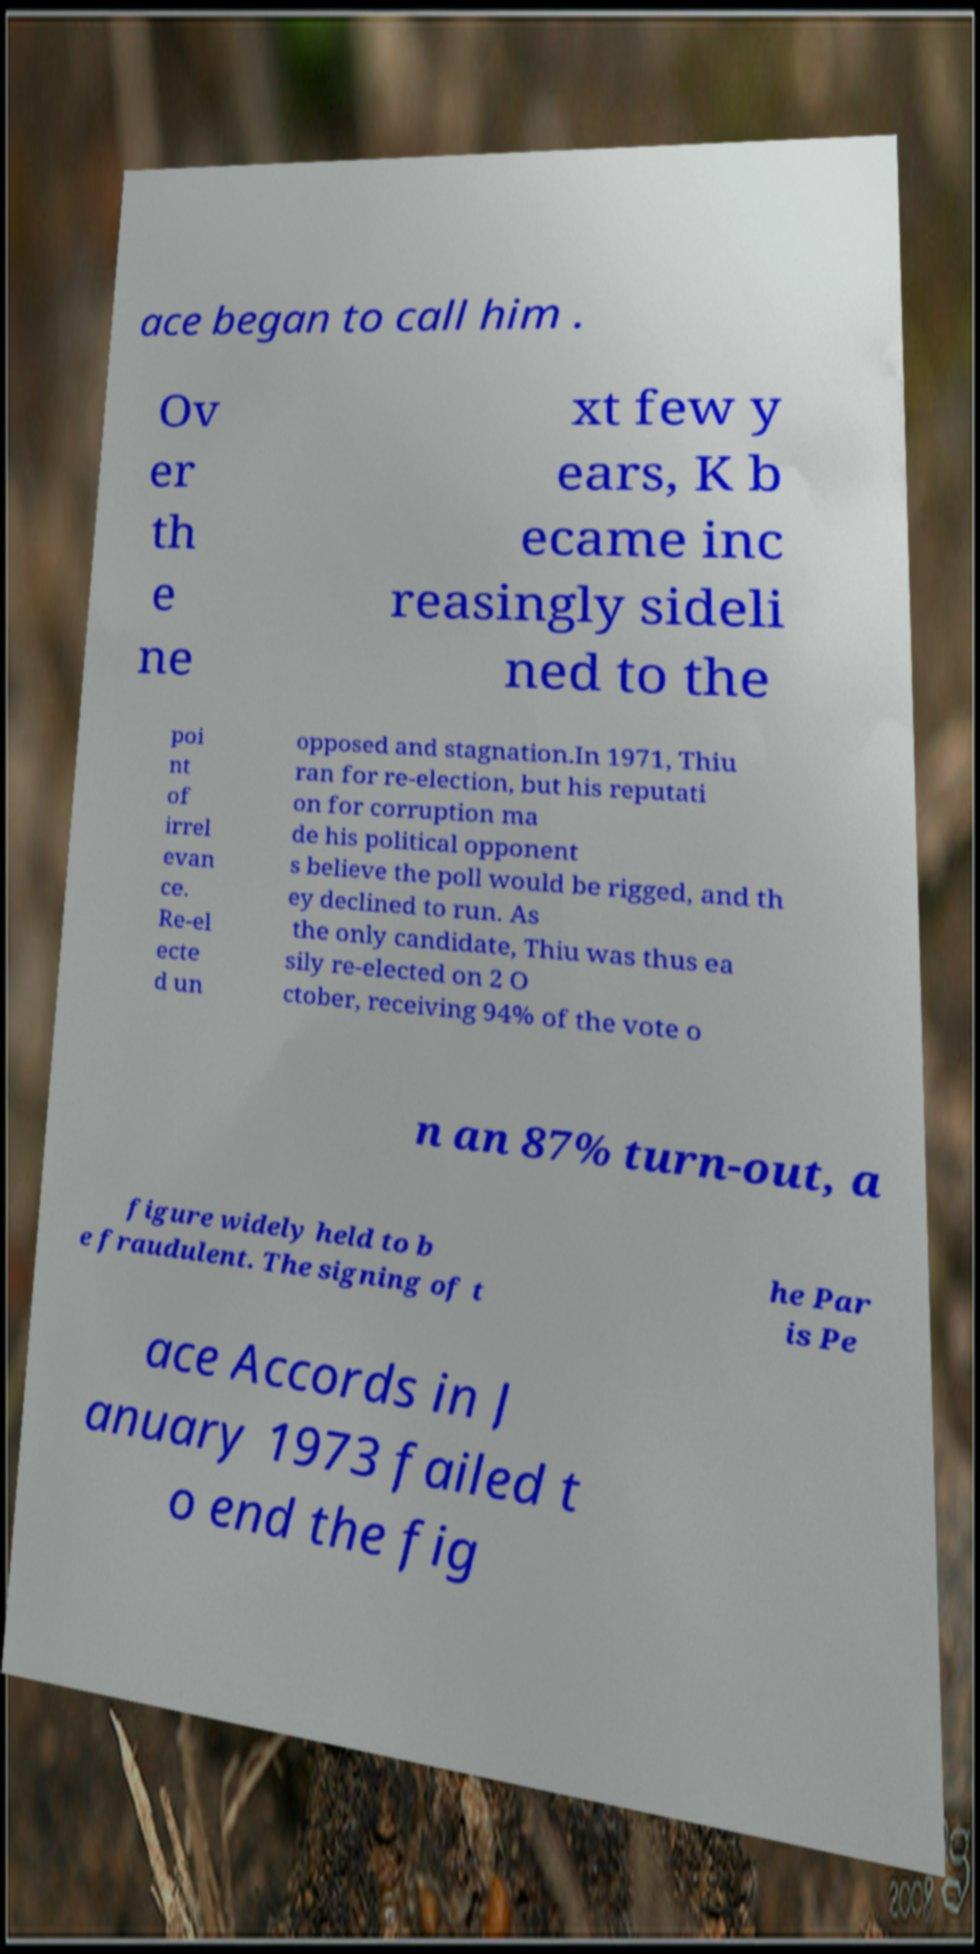Please read and relay the text visible in this image. What does it say? ace began to call him . Ov er th e ne xt few y ears, K b ecame inc reasingly sideli ned to the poi nt of irrel evan ce. Re-el ecte d un opposed and stagnation.In 1971, Thiu ran for re-election, but his reputati on for corruption ma de his political opponent s believe the poll would be rigged, and th ey declined to run. As the only candidate, Thiu was thus ea sily re-elected on 2 O ctober, receiving 94% of the vote o n an 87% turn-out, a figure widely held to b e fraudulent. The signing of t he Par is Pe ace Accords in J anuary 1973 failed t o end the fig 